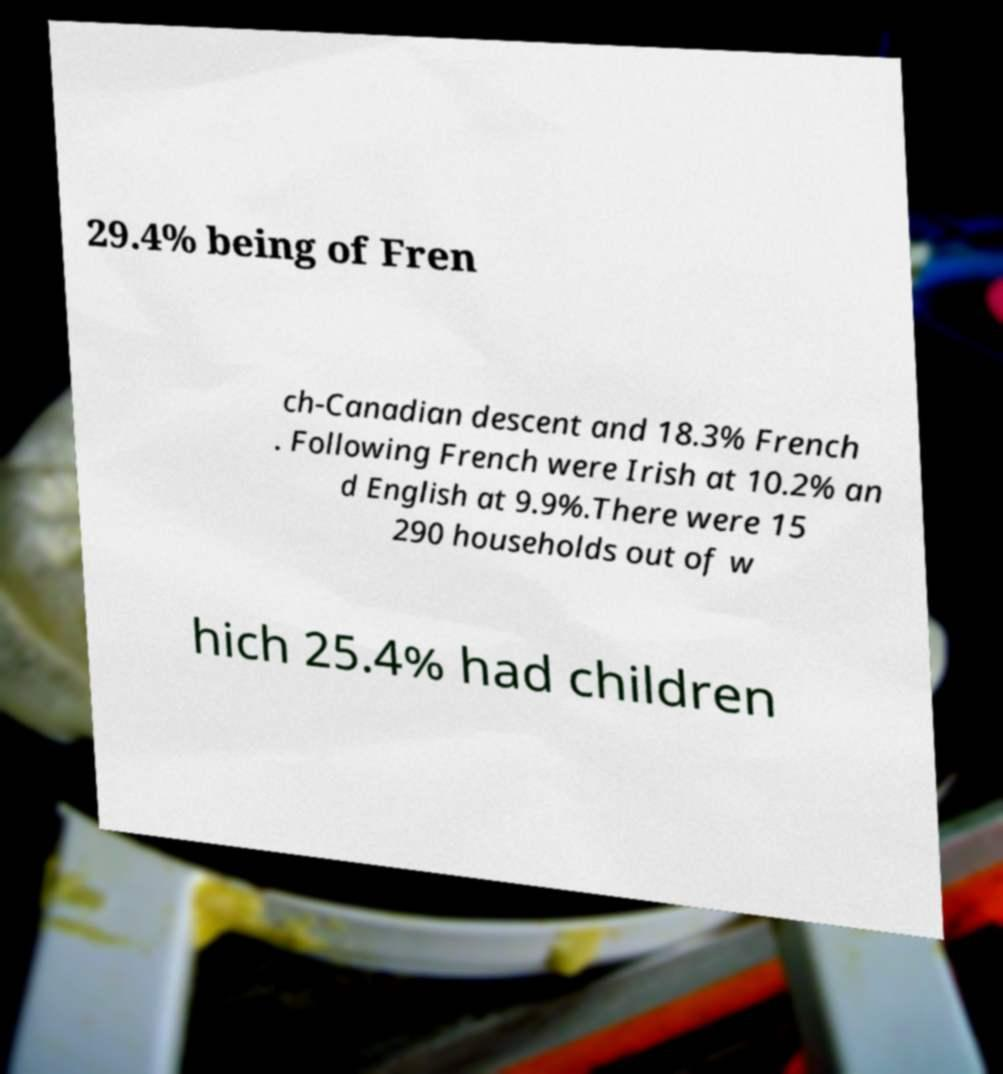Can you accurately transcribe the text from the provided image for me? 29.4% being of Fren ch-Canadian descent and 18.3% French . Following French were Irish at 10.2% an d English at 9.9%.There were 15 290 households out of w hich 25.4% had children 